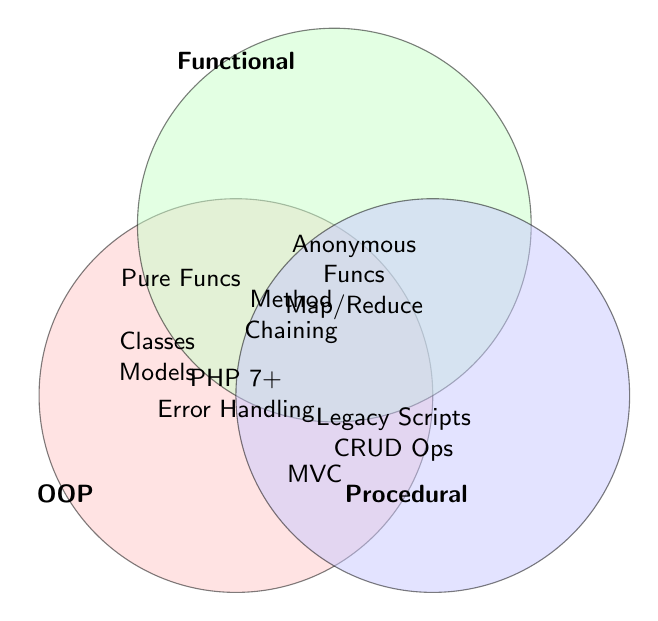What are the three main categories in the Venn diagram? The three main categories are labeled as "OOP" (Object-Oriented Programming), "Functional", and "Procedural".
Answer: OOP, Functional, Procedural Which paradigms are common to all three categories? From the position at the intersection of all three circles, it shows "PHP 7+ Features" and "Error Handling".
Answer: PHP 7+ Features, Error Handling What concepts fall only under the Procedural category in the Venn diagram? Concepts exclusive to the Procedural circle are "Legacy PHP Scripts" and "Simple CRUD Operations".
Answer: Legacy PHP Scripts, Simple CRUD Operations Which paradigms are shared between OOP and Functional categories? At the intersection of OOP and Functional circles, the diagram shows "Method Chaining" and "Dependency Injection".
Answer: Method Chaining, Dependency Injection Does the concept of "Pure Functions" belong to any combination of two categories? Yes, "Pure Functions" is located at the intersection of Functional and Procedural circles.
Answer: Yes How many paradigms are specific to Object-Oriented Programming? The paradigms listed solely in the Object-Oriented circle are "PHP Classes", "Laravel Models", and "Symfony Entities". This adds up to three.
Answer: Three Are there any paradigms that fall into the overlap between OOP and Procedural categories? Yes, there is one paradigm in the overlap between OOP and Procedural categories, which is "MVC Architecture".
Answer: Yes Which concept found in the Functional category involves working with arrays? The concept involving arrays in the Functional circle is "Array Map/Reduce".
Answer: Array Map/Reduce What paradigm is shared between OOP and Functional categories that isn't shared with Procedural? "Dependency Injection" is shared between OOP and Functional but not with Procedural.
Answer: Dependency Injection 